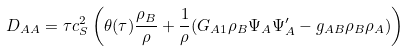Convert formula to latex. <formula><loc_0><loc_0><loc_500><loc_500>D _ { A A } = \tau c _ { S } ^ { 2 } \left ( \theta ( \tau ) \frac { \rho _ { B } } { \rho } + \frac { 1 } { \rho } ( G _ { A 1 } \rho _ { B } \Psi _ { A } \Psi ^ { \prime } _ { A } - g _ { A B } \rho _ { B } \rho _ { A } ) \right )</formula> 